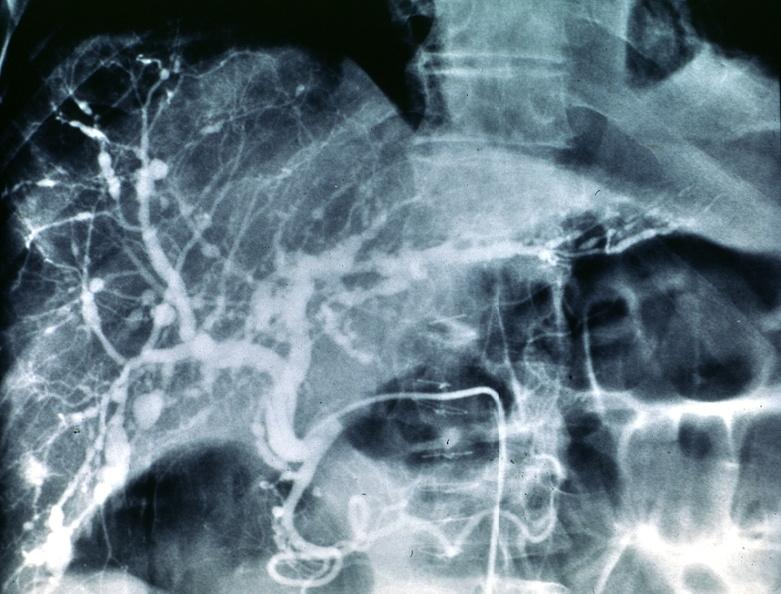s heel ulcer present?
Answer the question using a single word or phrase. No 